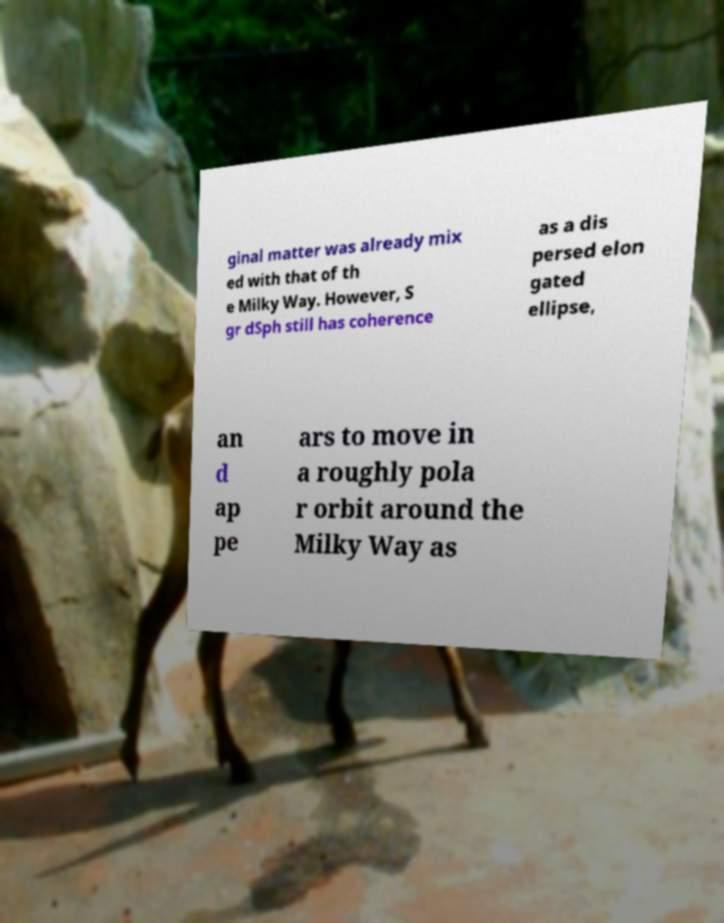Could you extract and type out the text from this image? ginal matter was already mix ed with that of th e Milky Way. However, S gr dSph still has coherence as a dis persed elon gated ellipse, an d ap pe ars to move in a roughly pola r orbit around the Milky Way as 